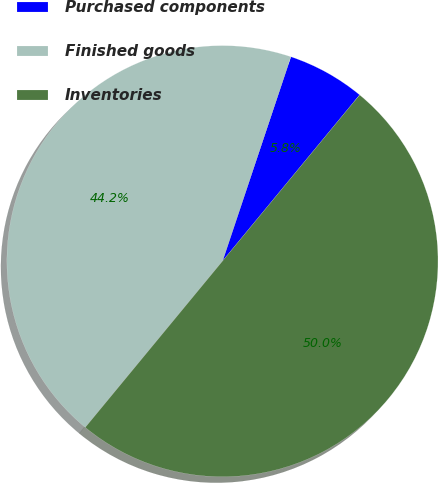<chart> <loc_0><loc_0><loc_500><loc_500><pie_chart><fcel>Purchased components<fcel>Finished goods<fcel>Inventories<nl><fcel>5.84%<fcel>44.16%<fcel>50.0%<nl></chart> 